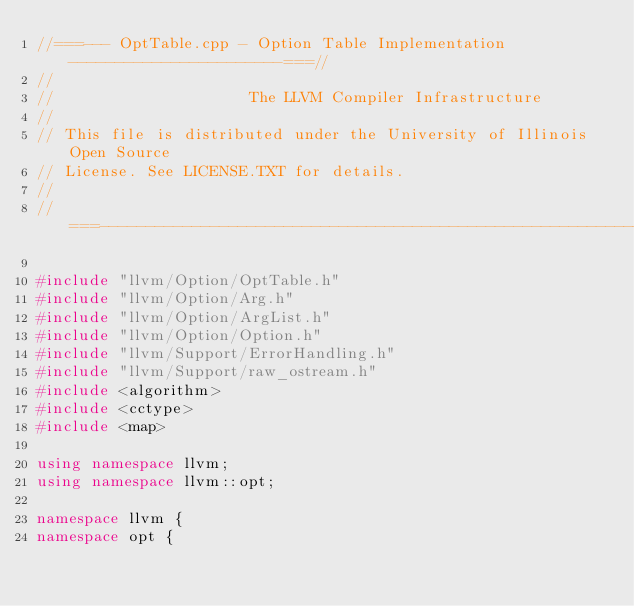Convert code to text. <code><loc_0><loc_0><loc_500><loc_500><_C++_>//===--- OptTable.cpp - Option Table Implementation -----------------------===//
//
//                     The LLVM Compiler Infrastructure
//
// This file is distributed under the University of Illinois Open Source
// License. See LICENSE.TXT for details.
//
//===----------------------------------------------------------------------===//

#include "llvm/Option/OptTable.h"
#include "llvm/Option/Arg.h"
#include "llvm/Option/ArgList.h"
#include "llvm/Option/Option.h"
#include "llvm/Support/ErrorHandling.h"
#include "llvm/Support/raw_ostream.h"
#include <algorithm>
#include <cctype>
#include <map>

using namespace llvm;
using namespace llvm::opt;

namespace llvm {
namespace opt {
</code> 